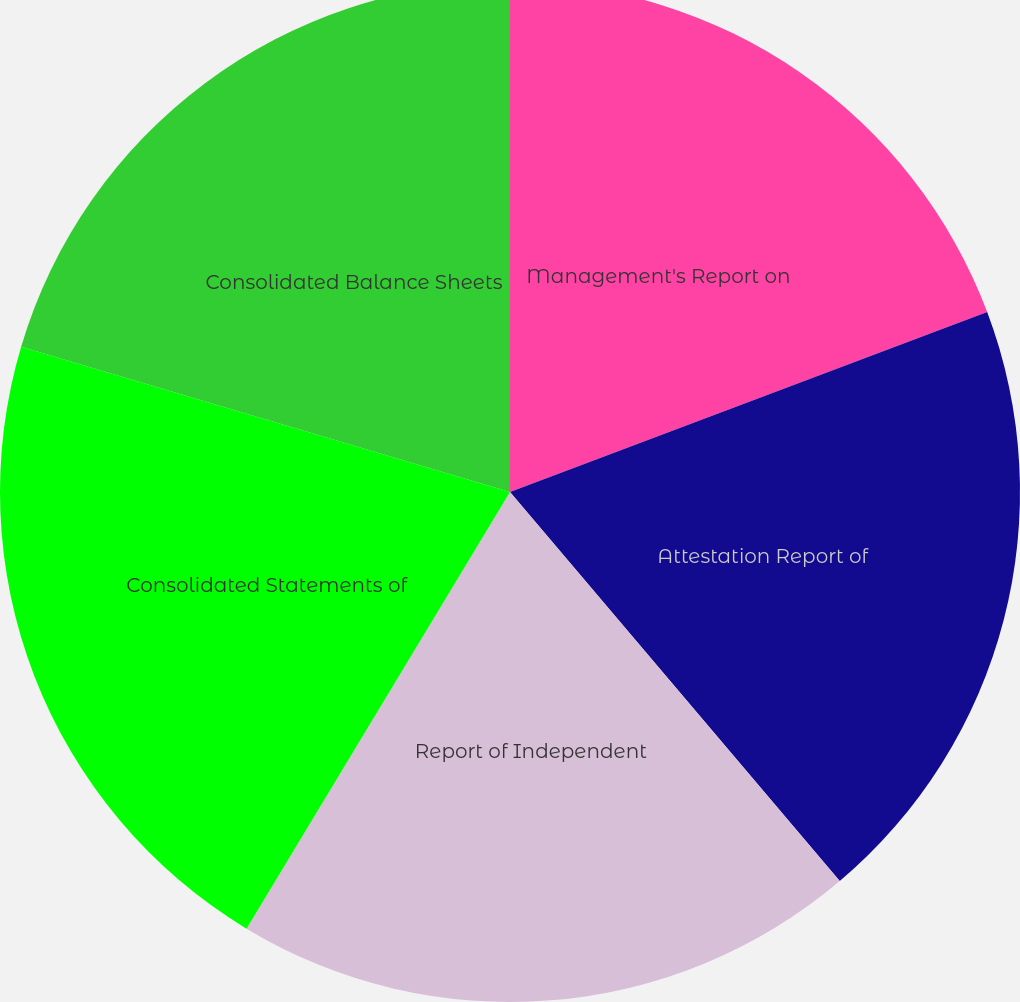Convert chart to OTSL. <chart><loc_0><loc_0><loc_500><loc_500><pie_chart><fcel>Management's Report on<fcel>Attestation Report of<fcel>Report of Independent<fcel>Consolidated Statements of<fcel>Consolidated Balance Sheets<nl><fcel>19.26%<fcel>19.55%<fcel>19.83%<fcel>20.96%<fcel>20.4%<nl></chart> 